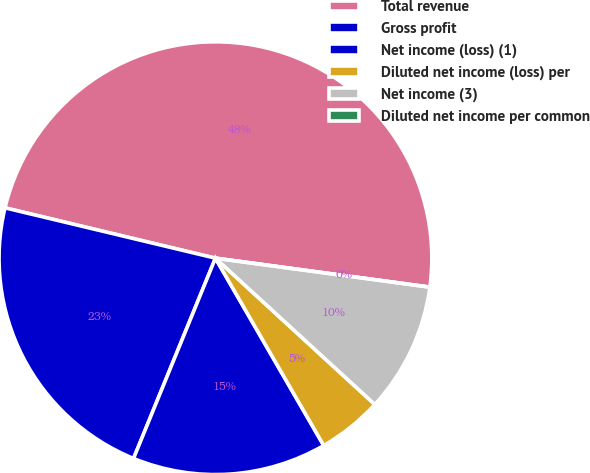<chart> <loc_0><loc_0><loc_500><loc_500><pie_chart><fcel>Total revenue<fcel>Gross profit<fcel>Net income (loss) (1)<fcel>Diluted net income (loss) per<fcel>Net income (3)<fcel>Diluted net income per common<nl><fcel>48.4%<fcel>22.56%<fcel>14.52%<fcel>4.84%<fcel>9.68%<fcel>0.0%<nl></chart> 